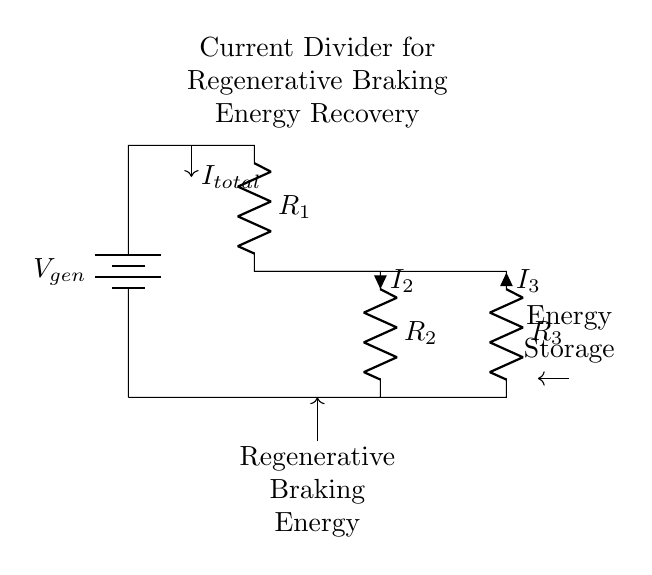What does the battery represent in this circuit? The battery represents the generated voltage, labeled as V_gen, which supplies electrical energy to the circuit.
Answer: V_gen What are the values of the resistors in this circuit? The circuit has three resistors represented as R_1, R_2, and R_3. The exact values are not specified in the diagram but are labeled accordingly.
Answer: R_1, R_2, R_3 What is the relationship between I_total and I_2? I_2 is one of the output currents in the current divider and is a portion of the total current I_total supplied by the battery, divided based on the resistances.
Answer: Portion of I_total How does the current divider operate in this circuit? The current divider distributes the total current I_total through the resistors R_1, R_2, and R_3. The amount of current through each resistor depends on its resistance value relative to the total resistance of the parallel circuit created.
Answer: Distributes total current based on resistance What type of energy is being managed by this circuit? The circuit is specifically designed for managing regenerative braking energy recovery in electric trains, allowing for renewable energy storage.
Answer: Regenerative braking energy 